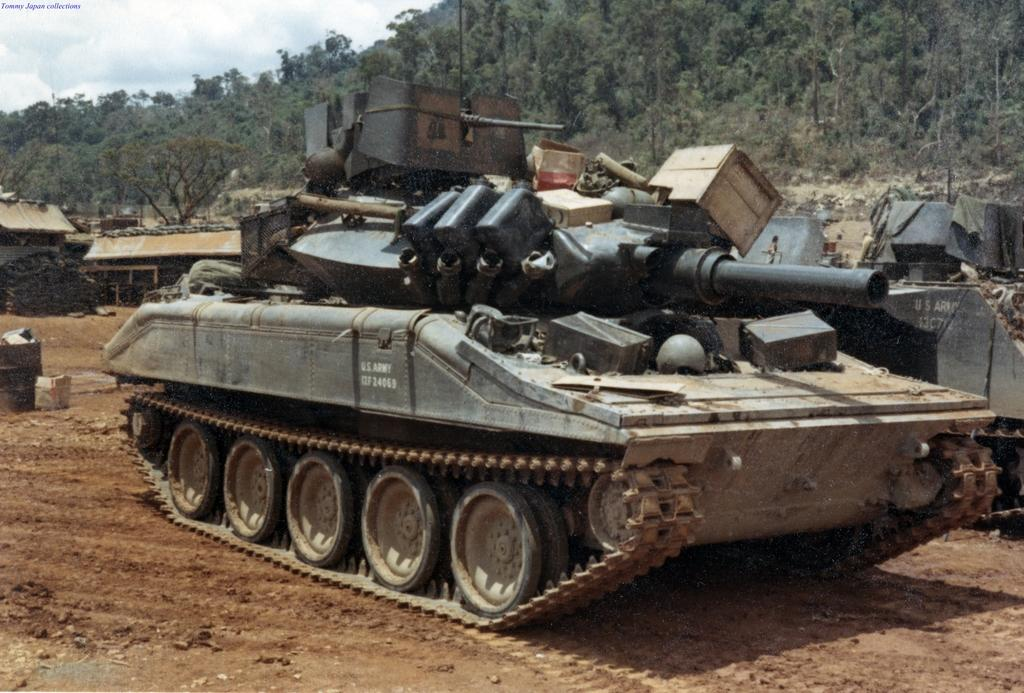What is the main subject of the image? The main subject of the image is a military tanker. Where is the military tanker located in the image? The military tanker is on the ground in the image. What type of structures can be seen in the image? There are sheds visible in the image. What can be seen in the background of the image? There are many trees and the sky visible in the background of the image. How many brothers are standing next to the military tanker in the image? There are no brothers present in the image; it only features a military tanker, sheds, trees, and the sky. What type of soda is being served from the military tanker in the image? There is no soda being served from the military tanker in the image; it is a military vehicle and not a food or beverage dispenser. 